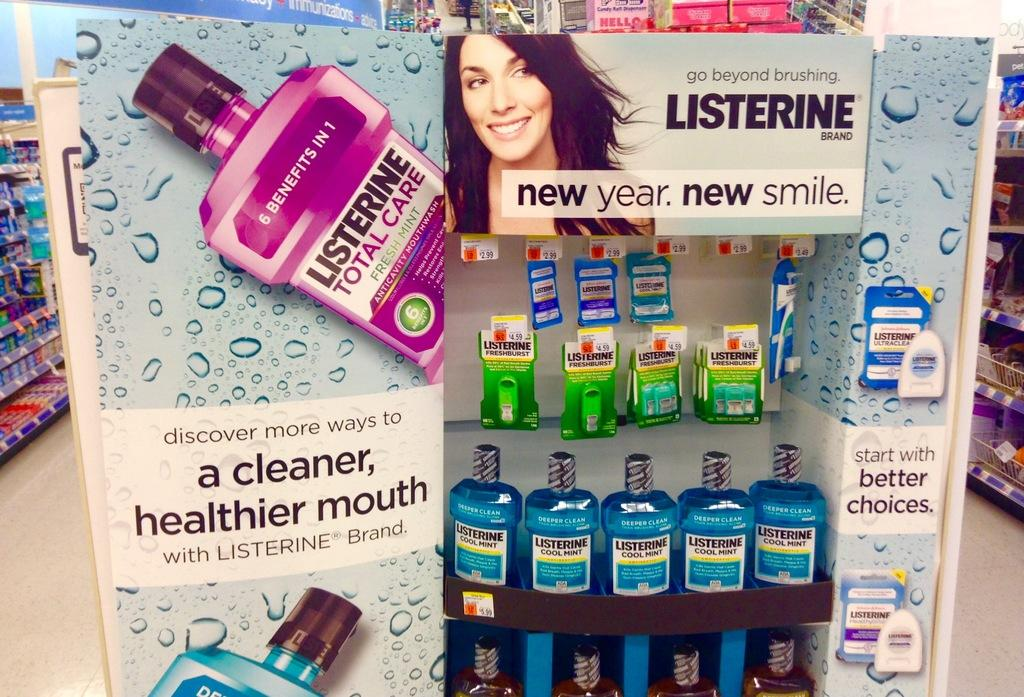<image>
Give a short and clear explanation of the subsequent image. A Listerine display at the end of an aisle in a store 